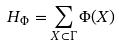Convert formula to latex. <formula><loc_0><loc_0><loc_500><loc_500>H _ { \Phi } = \sum _ { X \subset \Gamma } \Phi ( X )</formula> 